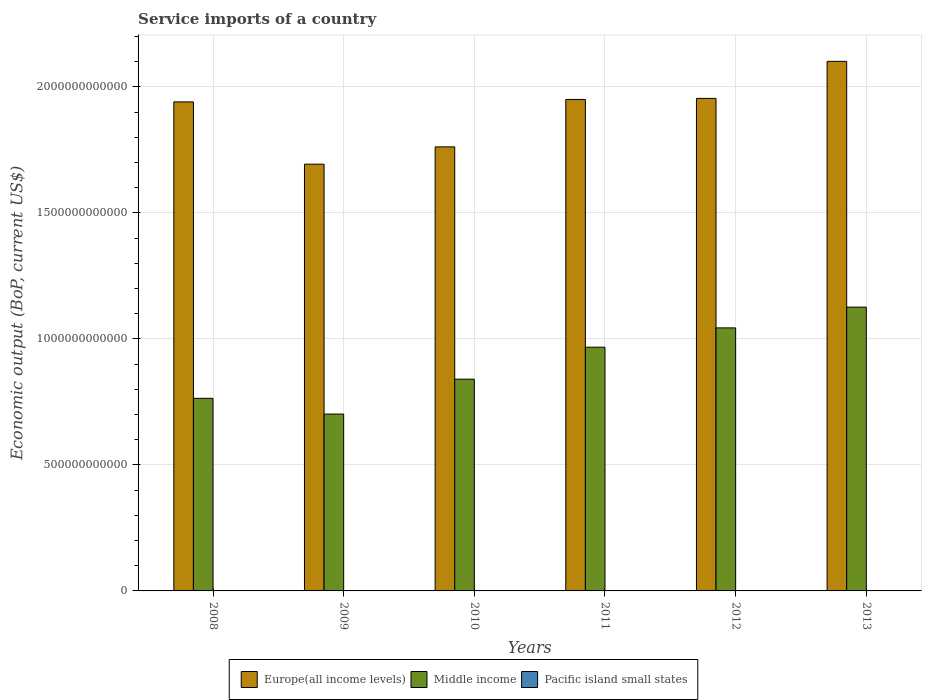How many different coloured bars are there?
Provide a succinct answer. 3. Are the number of bars on each tick of the X-axis equal?
Your answer should be very brief. Yes. How many bars are there on the 4th tick from the left?
Your answer should be very brief. 3. In how many cases, is the number of bars for a given year not equal to the number of legend labels?
Give a very brief answer. 0. What is the service imports in Europe(all income levels) in 2009?
Ensure brevity in your answer.  1.69e+12. Across all years, what is the maximum service imports in Europe(all income levels)?
Provide a succinct answer. 2.10e+12. Across all years, what is the minimum service imports in Pacific island small states?
Keep it short and to the point. 1.04e+09. In which year was the service imports in Europe(all income levels) maximum?
Your answer should be compact. 2013. What is the total service imports in Pacific island small states in the graph?
Ensure brevity in your answer.  7.42e+09. What is the difference between the service imports in Europe(all income levels) in 2008 and that in 2013?
Your response must be concise. -1.61e+11. What is the difference between the service imports in Pacific island small states in 2008 and the service imports in Europe(all income levels) in 2009?
Give a very brief answer. -1.69e+12. What is the average service imports in Middle income per year?
Keep it short and to the point. 9.07e+11. In the year 2010, what is the difference between the service imports in Middle income and service imports in Europe(all income levels)?
Your answer should be very brief. -9.22e+11. In how many years, is the service imports in Pacific island small states greater than 2100000000000 US$?
Give a very brief answer. 0. What is the ratio of the service imports in Pacific island small states in 2009 to that in 2011?
Your answer should be very brief. 0.82. Is the service imports in Middle income in 2011 less than that in 2012?
Your response must be concise. Yes. Is the difference between the service imports in Middle income in 2008 and 2011 greater than the difference between the service imports in Europe(all income levels) in 2008 and 2011?
Make the answer very short. No. What is the difference between the highest and the second highest service imports in Pacific island small states?
Offer a very short reply. 2.58e+07. What is the difference between the highest and the lowest service imports in Middle income?
Give a very brief answer. 4.24e+11. Is the sum of the service imports in Europe(all income levels) in 2010 and 2013 greater than the maximum service imports in Middle income across all years?
Offer a terse response. Yes. What does the 1st bar from the left in 2010 represents?
Keep it short and to the point. Europe(all income levels). What does the 1st bar from the right in 2011 represents?
Make the answer very short. Pacific island small states. Are all the bars in the graph horizontal?
Ensure brevity in your answer.  No. How many years are there in the graph?
Offer a terse response. 6. What is the difference between two consecutive major ticks on the Y-axis?
Ensure brevity in your answer.  5.00e+11. How are the legend labels stacked?
Provide a succinct answer. Horizontal. What is the title of the graph?
Provide a short and direct response. Service imports of a country. Does "Ghana" appear as one of the legend labels in the graph?
Keep it short and to the point. No. What is the label or title of the Y-axis?
Keep it short and to the point. Economic output (BoP, current US$). What is the Economic output (BoP, current US$) in Europe(all income levels) in 2008?
Provide a succinct answer. 1.94e+12. What is the Economic output (BoP, current US$) of Middle income in 2008?
Provide a succinct answer. 7.64e+11. What is the Economic output (BoP, current US$) of Pacific island small states in 2008?
Your answer should be compact. 1.25e+09. What is the Economic output (BoP, current US$) of Europe(all income levels) in 2009?
Your answer should be compact. 1.69e+12. What is the Economic output (BoP, current US$) in Middle income in 2009?
Your response must be concise. 7.02e+11. What is the Economic output (BoP, current US$) of Pacific island small states in 2009?
Ensure brevity in your answer.  1.04e+09. What is the Economic output (BoP, current US$) in Europe(all income levels) in 2010?
Ensure brevity in your answer.  1.76e+12. What is the Economic output (BoP, current US$) in Middle income in 2010?
Provide a succinct answer. 8.40e+11. What is the Economic output (BoP, current US$) of Pacific island small states in 2010?
Your answer should be very brief. 1.12e+09. What is the Economic output (BoP, current US$) of Europe(all income levels) in 2011?
Give a very brief answer. 1.95e+12. What is the Economic output (BoP, current US$) in Middle income in 2011?
Your answer should be very brief. 9.67e+11. What is the Economic output (BoP, current US$) of Pacific island small states in 2011?
Make the answer very short. 1.27e+09. What is the Economic output (BoP, current US$) of Europe(all income levels) in 2012?
Make the answer very short. 1.95e+12. What is the Economic output (BoP, current US$) of Middle income in 2012?
Your response must be concise. 1.04e+12. What is the Economic output (BoP, current US$) of Pacific island small states in 2012?
Give a very brief answer. 1.36e+09. What is the Economic output (BoP, current US$) in Europe(all income levels) in 2013?
Give a very brief answer. 2.10e+12. What is the Economic output (BoP, current US$) in Middle income in 2013?
Keep it short and to the point. 1.13e+12. What is the Economic output (BoP, current US$) in Pacific island small states in 2013?
Keep it short and to the point. 1.38e+09. Across all years, what is the maximum Economic output (BoP, current US$) in Europe(all income levels)?
Provide a short and direct response. 2.10e+12. Across all years, what is the maximum Economic output (BoP, current US$) in Middle income?
Ensure brevity in your answer.  1.13e+12. Across all years, what is the maximum Economic output (BoP, current US$) of Pacific island small states?
Your answer should be compact. 1.38e+09. Across all years, what is the minimum Economic output (BoP, current US$) of Europe(all income levels)?
Your response must be concise. 1.69e+12. Across all years, what is the minimum Economic output (BoP, current US$) of Middle income?
Make the answer very short. 7.02e+11. Across all years, what is the minimum Economic output (BoP, current US$) of Pacific island small states?
Provide a short and direct response. 1.04e+09. What is the total Economic output (BoP, current US$) of Europe(all income levels) in the graph?
Your answer should be compact. 1.14e+13. What is the total Economic output (BoP, current US$) in Middle income in the graph?
Provide a short and direct response. 5.44e+12. What is the total Economic output (BoP, current US$) of Pacific island small states in the graph?
Offer a very short reply. 7.42e+09. What is the difference between the Economic output (BoP, current US$) of Europe(all income levels) in 2008 and that in 2009?
Offer a very short reply. 2.47e+11. What is the difference between the Economic output (BoP, current US$) of Middle income in 2008 and that in 2009?
Offer a terse response. 6.24e+1. What is the difference between the Economic output (BoP, current US$) in Pacific island small states in 2008 and that in 2009?
Your answer should be compact. 2.09e+08. What is the difference between the Economic output (BoP, current US$) in Europe(all income levels) in 2008 and that in 2010?
Provide a short and direct response. 1.78e+11. What is the difference between the Economic output (BoP, current US$) of Middle income in 2008 and that in 2010?
Your response must be concise. -7.60e+1. What is the difference between the Economic output (BoP, current US$) of Pacific island small states in 2008 and that in 2010?
Ensure brevity in your answer.  1.35e+08. What is the difference between the Economic output (BoP, current US$) in Europe(all income levels) in 2008 and that in 2011?
Your answer should be compact. -9.67e+09. What is the difference between the Economic output (BoP, current US$) of Middle income in 2008 and that in 2011?
Give a very brief answer. -2.03e+11. What is the difference between the Economic output (BoP, current US$) of Pacific island small states in 2008 and that in 2011?
Ensure brevity in your answer.  -2.08e+07. What is the difference between the Economic output (BoP, current US$) of Europe(all income levels) in 2008 and that in 2012?
Provide a short and direct response. -1.39e+1. What is the difference between the Economic output (BoP, current US$) of Middle income in 2008 and that in 2012?
Provide a short and direct response. -2.80e+11. What is the difference between the Economic output (BoP, current US$) in Pacific island small states in 2008 and that in 2012?
Your answer should be compact. -1.06e+08. What is the difference between the Economic output (BoP, current US$) of Europe(all income levels) in 2008 and that in 2013?
Keep it short and to the point. -1.61e+11. What is the difference between the Economic output (BoP, current US$) of Middle income in 2008 and that in 2013?
Provide a short and direct response. -3.62e+11. What is the difference between the Economic output (BoP, current US$) in Pacific island small states in 2008 and that in 2013?
Offer a terse response. -1.32e+08. What is the difference between the Economic output (BoP, current US$) in Europe(all income levels) in 2009 and that in 2010?
Provide a succinct answer. -6.86e+1. What is the difference between the Economic output (BoP, current US$) in Middle income in 2009 and that in 2010?
Ensure brevity in your answer.  -1.38e+11. What is the difference between the Economic output (BoP, current US$) in Pacific island small states in 2009 and that in 2010?
Your answer should be very brief. -7.35e+07. What is the difference between the Economic output (BoP, current US$) in Europe(all income levels) in 2009 and that in 2011?
Provide a succinct answer. -2.57e+11. What is the difference between the Economic output (BoP, current US$) in Middle income in 2009 and that in 2011?
Provide a succinct answer. -2.65e+11. What is the difference between the Economic output (BoP, current US$) of Pacific island small states in 2009 and that in 2011?
Your answer should be very brief. -2.29e+08. What is the difference between the Economic output (BoP, current US$) in Europe(all income levels) in 2009 and that in 2012?
Your response must be concise. -2.61e+11. What is the difference between the Economic output (BoP, current US$) in Middle income in 2009 and that in 2012?
Offer a terse response. -3.42e+11. What is the difference between the Economic output (BoP, current US$) of Pacific island small states in 2009 and that in 2012?
Keep it short and to the point. -3.15e+08. What is the difference between the Economic output (BoP, current US$) in Europe(all income levels) in 2009 and that in 2013?
Your answer should be very brief. -4.08e+11. What is the difference between the Economic output (BoP, current US$) in Middle income in 2009 and that in 2013?
Your response must be concise. -4.24e+11. What is the difference between the Economic output (BoP, current US$) of Pacific island small states in 2009 and that in 2013?
Ensure brevity in your answer.  -3.41e+08. What is the difference between the Economic output (BoP, current US$) of Europe(all income levels) in 2010 and that in 2011?
Offer a terse response. -1.88e+11. What is the difference between the Economic output (BoP, current US$) of Middle income in 2010 and that in 2011?
Ensure brevity in your answer.  -1.27e+11. What is the difference between the Economic output (BoP, current US$) of Pacific island small states in 2010 and that in 2011?
Offer a very short reply. -1.56e+08. What is the difference between the Economic output (BoP, current US$) of Europe(all income levels) in 2010 and that in 2012?
Provide a short and direct response. -1.92e+11. What is the difference between the Economic output (BoP, current US$) in Middle income in 2010 and that in 2012?
Provide a short and direct response. -2.04e+11. What is the difference between the Economic output (BoP, current US$) in Pacific island small states in 2010 and that in 2012?
Your response must be concise. -2.41e+08. What is the difference between the Economic output (BoP, current US$) of Europe(all income levels) in 2010 and that in 2013?
Provide a succinct answer. -3.39e+11. What is the difference between the Economic output (BoP, current US$) of Middle income in 2010 and that in 2013?
Provide a short and direct response. -2.86e+11. What is the difference between the Economic output (BoP, current US$) in Pacific island small states in 2010 and that in 2013?
Give a very brief answer. -2.67e+08. What is the difference between the Economic output (BoP, current US$) of Europe(all income levels) in 2011 and that in 2012?
Offer a very short reply. -4.20e+09. What is the difference between the Economic output (BoP, current US$) in Middle income in 2011 and that in 2012?
Provide a short and direct response. -7.66e+1. What is the difference between the Economic output (BoP, current US$) in Pacific island small states in 2011 and that in 2012?
Offer a terse response. -8.54e+07. What is the difference between the Economic output (BoP, current US$) of Europe(all income levels) in 2011 and that in 2013?
Keep it short and to the point. -1.51e+11. What is the difference between the Economic output (BoP, current US$) of Middle income in 2011 and that in 2013?
Offer a terse response. -1.59e+11. What is the difference between the Economic output (BoP, current US$) of Pacific island small states in 2011 and that in 2013?
Provide a succinct answer. -1.11e+08. What is the difference between the Economic output (BoP, current US$) of Europe(all income levels) in 2012 and that in 2013?
Ensure brevity in your answer.  -1.47e+11. What is the difference between the Economic output (BoP, current US$) in Middle income in 2012 and that in 2013?
Offer a very short reply. -8.24e+1. What is the difference between the Economic output (BoP, current US$) of Pacific island small states in 2012 and that in 2013?
Give a very brief answer. -2.58e+07. What is the difference between the Economic output (BoP, current US$) in Europe(all income levels) in 2008 and the Economic output (BoP, current US$) in Middle income in 2009?
Give a very brief answer. 1.24e+12. What is the difference between the Economic output (BoP, current US$) in Europe(all income levels) in 2008 and the Economic output (BoP, current US$) in Pacific island small states in 2009?
Your answer should be compact. 1.94e+12. What is the difference between the Economic output (BoP, current US$) in Middle income in 2008 and the Economic output (BoP, current US$) in Pacific island small states in 2009?
Give a very brief answer. 7.63e+11. What is the difference between the Economic output (BoP, current US$) of Europe(all income levels) in 2008 and the Economic output (BoP, current US$) of Middle income in 2010?
Your answer should be compact. 1.10e+12. What is the difference between the Economic output (BoP, current US$) of Europe(all income levels) in 2008 and the Economic output (BoP, current US$) of Pacific island small states in 2010?
Offer a terse response. 1.94e+12. What is the difference between the Economic output (BoP, current US$) in Middle income in 2008 and the Economic output (BoP, current US$) in Pacific island small states in 2010?
Offer a terse response. 7.63e+11. What is the difference between the Economic output (BoP, current US$) in Europe(all income levels) in 2008 and the Economic output (BoP, current US$) in Middle income in 2011?
Provide a succinct answer. 9.73e+11. What is the difference between the Economic output (BoP, current US$) in Europe(all income levels) in 2008 and the Economic output (BoP, current US$) in Pacific island small states in 2011?
Your response must be concise. 1.94e+12. What is the difference between the Economic output (BoP, current US$) of Middle income in 2008 and the Economic output (BoP, current US$) of Pacific island small states in 2011?
Provide a succinct answer. 7.63e+11. What is the difference between the Economic output (BoP, current US$) in Europe(all income levels) in 2008 and the Economic output (BoP, current US$) in Middle income in 2012?
Offer a very short reply. 8.97e+11. What is the difference between the Economic output (BoP, current US$) of Europe(all income levels) in 2008 and the Economic output (BoP, current US$) of Pacific island small states in 2012?
Ensure brevity in your answer.  1.94e+12. What is the difference between the Economic output (BoP, current US$) of Middle income in 2008 and the Economic output (BoP, current US$) of Pacific island small states in 2012?
Offer a terse response. 7.63e+11. What is the difference between the Economic output (BoP, current US$) of Europe(all income levels) in 2008 and the Economic output (BoP, current US$) of Middle income in 2013?
Make the answer very short. 8.14e+11. What is the difference between the Economic output (BoP, current US$) in Europe(all income levels) in 2008 and the Economic output (BoP, current US$) in Pacific island small states in 2013?
Offer a terse response. 1.94e+12. What is the difference between the Economic output (BoP, current US$) in Middle income in 2008 and the Economic output (BoP, current US$) in Pacific island small states in 2013?
Keep it short and to the point. 7.63e+11. What is the difference between the Economic output (BoP, current US$) of Europe(all income levels) in 2009 and the Economic output (BoP, current US$) of Middle income in 2010?
Your answer should be compact. 8.53e+11. What is the difference between the Economic output (BoP, current US$) in Europe(all income levels) in 2009 and the Economic output (BoP, current US$) in Pacific island small states in 2010?
Keep it short and to the point. 1.69e+12. What is the difference between the Economic output (BoP, current US$) in Middle income in 2009 and the Economic output (BoP, current US$) in Pacific island small states in 2010?
Keep it short and to the point. 7.01e+11. What is the difference between the Economic output (BoP, current US$) in Europe(all income levels) in 2009 and the Economic output (BoP, current US$) in Middle income in 2011?
Offer a terse response. 7.26e+11. What is the difference between the Economic output (BoP, current US$) of Europe(all income levels) in 2009 and the Economic output (BoP, current US$) of Pacific island small states in 2011?
Provide a short and direct response. 1.69e+12. What is the difference between the Economic output (BoP, current US$) of Middle income in 2009 and the Economic output (BoP, current US$) of Pacific island small states in 2011?
Your answer should be very brief. 7.00e+11. What is the difference between the Economic output (BoP, current US$) in Europe(all income levels) in 2009 and the Economic output (BoP, current US$) in Middle income in 2012?
Provide a succinct answer. 6.50e+11. What is the difference between the Economic output (BoP, current US$) of Europe(all income levels) in 2009 and the Economic output (BoP, current US$) of Pacific island small states in 2012?
Ensure brevity in your answer.  1.69e+12. What is the difference between the Economic output (BoP, current US$) in Middle income in 2009 and the Economic output (BoP, current US$) in Pacific island small states in 2012?
Your response must be concise. 7.00e+11. What is the difference between the Economic output (BoP, current US$) in Europe(all income levels) in 2009 and the Economic output (BoP, current US$) in Middle income in 2013?
Offer a very short reply. 5.67e+11. What is the difference between the Economic output (BoP, current US$) of Europe(all income levels) in 2009 and the Economic output (BoP, current US$) of Pacific island small states in 2013?
Provide a short and direct response. 1.69e+12. What is the difference between the Economic output (BoP, current US$) in Middle income in 2009 and the Economic output (BoP, current US$) in Pacific island small states in 2013?
Ensure brevity in your answer.  7.00e+11. What is the difference between the Economic output (BoP, current US$) in Europe(all income levels) in 2010 and the Economic output (BoP, current US$) in Middle income in 2011?
Keep it short and to the point. 7.95e+11. What is the difference between the Economic output (BoP, current US$) of Europe(all income levels) in 2010 and the Economic output (BoP, current US$) of Pacific island small states in 2011?
Offer a very short reply. 1.76e+12. What is the difference between the Economic output (BoP, current US$) of Middle income in 2010 and the Economic output (BoP, current US$) of Pacific island small states in 2011?
Provide a short and direct response. 8.39e+11. What is the difference between the Economic output (BoP, current US$) in Europe(all income levels) in 2010 and the Economic output (BoP, current US$) in Middle income in 2012?
Your answer should be very brief. 7.18e+11. What is the difference between the Economic output (BoP, current US$) of Europe(all income levels) in 2010 and the Economic output (BoP, current US$) of Pacific island small states in 2012?
Offer a very short reply. 1.76e+12. What is the difference between the Economic output (BoP, current US$) of Middle income in 2010 and the Economic output (BoP, current US$) of Pacific island small states in 2012?
Keep it short and to the point. 8.39e+11. What is the difference between the Economic output (BoP, current US$) in Europe(all income levels) in 2010 and the Economic output (BoP, current US$) in Middle income in 2013?
Provide a short and direct response. 6.36e+11. What is the difference between the Economic output (BoP, current US$) in Europe(all income levels) in 2010 and the Economic output (BoP, current US$) in Pacific island small states in 2013?
Make the answer very short. 1.76e+12. What is the difference between the Economic output (BoP, current US$) of Middle income in 2010 and the Economic output (BoP, current US$) of Pacific island small states in 2013?
Your answer should be very brief. 8.39e+11. What is the difference between the Economic output (BoP, current US$) of Europe(all income levels) in 2011 and the Economic output (BoP, current US$) of Middle income in 2012?
Give a very brief answer. 9.06e+11. What is the difference between the Economic output (BoP, current US$) of Europe(all income levels) in 2011 and the Economic output (BoP, current US$) of Pacific island small states in 2012?
Ensure brevity in your answer.  1.95e+12. What is the difference between the Economic output (BoP, current US$) of Middle income in 2011 and the Economic output (BoP, current US$) of Pacific island small states in 2012?
Your answer should be compact. 9.66e+11. What is the difference between the Economic output (BoP, current US$) in Europe(all income levels) in 2011 and the Economic output (BoP, current US$) in Middle income in 2013?
Your answer should be compact. 8.24e+11. What is the difference between the Economic output (BoP, current US$) of Europe(all income levels) in 2011 and the Economic output (BoP, current US$) of Pacific island small states in 2013?
Your answer should be compact. 1.95e+12. What is the difference between the Economic output (BoP, current US$) in Middle income in 2011 and the Economic output (BoP, current US$) in Pacific island small states in 2013?
Provide a succinct answer. 9.66e+11. What is the difference between the Economic output (BoP, current US$) of Europe(all income levels) in 2012 and the Economic output (BoP, current US$) of Middle income in 2013?
Offer a very short reply. 8.28e+11. What is the difference between the Economic output (BoP, current US$) of Europe(all income levels) in 2012 and the Economic output (BoP, current US$) of Pacific island small states in 2013?
Keep it short and to the point. 1.95e+12. What is the difference between the Economic output (BoP, current US$) in Middle income in 2012 and the Economic output (BoP, current US$) in Pacific island small states in 2013?
Your response must be concise. 1.04e+12. What is the average Economic output (BoP, current US$) in Europe(all income levels) per year?
Make the answer very short. 1.90e+12. What is the average Economic output (BoP, current US$) in Middle income per year?
Provide a succinct answer. 9.07e+11. What is the average Economic output (BoP, current US$) in Pacific island small states per year?
Your answer should be compact. 1.24e+09. In the year 2008, what is the difference between the Economic output (BoP, current US$) of Europe(all income levels) and Economic output (BoP, current US$) of Middle income?
Offer a very short reply. 1.18e+12. In the year 2008, what is the difference between the Economic output (BoP, current US$) of Europe(all income levels) and Economic output (BoP, current US$) of Pacific island small states?
Offer a terse response. 1.94e+12. In the year 2008, what is the difference between the Economic output (BoP, current US$) in Middle income and Economic output (BoP, current US$) in Pacific island small states?
Make the answer very short. 7.63e+11. In the year 2009, what is the difference between the Economic output (BoP, current US$) in Europe(all income levels) and Economic output (BoP, current US$) in Middle income?
Ensure brevity in your answer.  9.91e+11. In the year 2009, what is the difference between the Economic output (BoP, current US$) in Europe(all income levels) and Economic output (BoP, current US$) in Pacific island small states?
Provide a short and direct response. 1.69e+12. In the year 2009, what is the difference between the Economic output (BoP, current US$) in Middle income and Economic output (BoP, current US$) in Pacific island small states?
Provide a succinct answer. 7.01e+11. In the year 2010, what is the difference between the Economic output (BoP, current US$) in Europe(all income levels) and Economic output (BoP, current US$) in Middle income?
Make the answer very short. 9.22e+11. In the year 2010, what is the difference between the Economic output (BoP, current US$) of Europe(all income levels) and Economic output (BoP, current US$) of Pacific island small states?
Your answer should be compact. 1.76e+12. In the year 2010, what is the difference between the Economic output (BoP, current US$) of Middle income and Economic output (BoP, current US$) of Pacific island small states?
Give a very brief answer. 8.39e+11. In the year 2011, what is the difference between the Economic output (BoP, current US$) in Europe(all income levels) and Economic output (BoP, current US$) in Middle income?
Provide a short and direct response. 9.83e+11. In the year 2011, what is the difference between the Economic output (BoP, current US$) of Europe(all income levels) and Economic output (BoP, current US$) of Pacific island small states?
Ensure brevity in your answer.  1.95e+12. In the year 2011, what is the difference between the Economic output (BoP, current US$) of Middle income and Economic output (BoP, current US$) of Pacific island small states?
Provide a succinct answer. 9.66e+11. In the year 2012, what is the difference between the Economic output (BoP, current US$) of Europe(all income levels) and Economic output (BoP, current US$) of Middle income?
Ensure brevity in your answer.  9.10e+11. In the year 2012, what is the difference between the Economic output (BoP, current US$) of Europe(all income levels) and Economic output (BoP, current US$) of Pacific island small states?
Ensure brevity in your answer.  1.95e+12. In the year 2012, what is the difference between the Economic output (BoP, current US$) in Middle income and Economic output (BoP, current US$) in Pacific island small states?
Offer a very short reply. 1.04e+12. In the year 2013, what is the difference between the Economic output (BoP, current US$) of Europe(all income levels) and Economic output (BoP, current US$) of Middle income?
Provide a succinct answer. 9.75e+11. In the year 2013, what is the difference between the Economic output (BoP, current US$) of Europe(all income levels) and Economic output (BoP, current US$) of Pacific island small states?
Ensure brevity in your answer.  2.10e+12. In the year 2013, what is the difference between the Economic output (BoP, current US$) of Middle income and Economic output (BoP, current US$) of Pacific island small states?
Your response must be concise. 1.12e+12. What is the ratio of the Economic output (BoP, current US$) of Europe(all income levels) in 2008 to that in 2009?
Your response must be concise. 1.15. What is the ratio of the Economic output (BoP, current US$) in Middle income in 2008 to that in 2009?
Offer a terse response. 1.09. What is the ratio of the Economic output (BoP, current US$) in Pacific island small states in 2008 to that in 2009?
Keep it short and to the point. 1.2. What is the ratio of the Economic output (BoP, current US$) of Europe(all income levels) in 2008 to that in 2010?
Offer a terse response. 1.1. What is the ratio of the Economic output (BoP, current US$) of Middle income in 2008 to that in 2010?
Give a very brief answer. 0.91. What is the ratio of the Economic output (BoP, current US$) of Pacific island small states in 2008 to that in 2010?
Give a very brief answer. 1.12. What is the ratio of the Economic output (BoP, current US$) in Middle income in 2008 to that in 2011?
Ensure brevity in your answer.  0.79. What is the ratio of the Economic output (BoP, current US$) of Pacific island small states in 2008 to that in 2011?
Keep it short and to the point. 0.98. What is the ratio of the Economic output (BoP, current US$) of Europe(all income levels) in 2008 to that in 2012?
Provide a succinct answer. 0.99. What is the ratio of the Economic output (BoP, current US$) of Middle income in 2008 to that in 2012?
Your response must be concise. 0.73. What is the ratio of the Economic output (BoP, current US$) of Pacific island small states in 2008 to that in 2012?
Offer a very short reply. 0.92. What is the ratio of the Economic output (BoP, current US$) of Europe(all income levels) in 2008 to that in 2013?
Offer a very short reply. 0.92. What is the ratio of the Economic output (BoP, current US$) in Middle income in 2008 to that in 2013?
Your answer should be compact. 0.68. What is the ratio of the Economic output (BoP, current US$) of Pacific island small states in 2008 to that in 2013?
Ensure brevity in your answer.  0.9. What is the ratio of the Economic output (BoP, current US$) of Europe(all income levels) in 2009 to that in 2010?
Ensure brevity in your answer.  0.96. What is the ratio of the Economic output (BoP, current US$) of Middle income in 2009 to that in 2010?
Your answer should be very brief. 0.84. What is the ratio of the Economic output (BoP, current US$) of Pacific island small states in 2009 to that in 2010?
Ensure brevity in your answer.  0.93. What is the ratio of the Economic output (BoP, current US$) of Europe(all income levels) in 2009 to that in 2011?
Your answer should be very brief. 0.87. What is the ratio of the Economic output (BoP, current US$) in Middle income in 2009 to that in 2011?
Provide a short and direct response. 0.73. What is the ratio of the Economic output (BoP, current US$) in Pacific island small states in 2009 to that in 2011?
Give a very brief answer. 0.82. What is the ratio of the Economic output (BoP, current US$) of Europe(all income levels) in 2009 to that in 2012?
Make the answer very short. 0.87. What is the ratio of the Economic output (BoP, current US$) in Middle income in 2009 to that in 2012?
Make the answer very short. 0.67. What is the ratio of the Economic output (BoP, current US$) in Pacific island small states in 2009 to that in 2012?
Give a very brief answer. 0.77. What is the ratio of the Economic output (BoP, current US$) of Europe(all income levels) in 2009 to that in 2013?
Keep it short and to the point. 0.81. What is the ratio of the Economic output (BoP, current US$) in Middle income in 2009 to that in 2013?
Provide a short and direct response. 0.62. What is the ratio of the Economic output (BoP, current US$) in Pacific island small states in 2009 to that in 2013?
Your response must be concise. 0.75. What is the ratio of the Economic output (BoP, current US$) in Europe(all income levels) in 2010 to that in 2011?
Make the answer very short. 0.9. What is the ratio of the Economic output (BoP, current US$) in Middle income in 2010 to that in 2011?
Provide a short and direct response. 0.87. What is the ratio of the Economic output (BoP, current US$) in Pacific island small states in 2010 to that in 2011?
Offer a terse response. 0.88. What is the ratio of the Economic output (BoP, current US$) in Europe(all income levels) in 2010 to that in 2012?
Your answer should be very brief. 0.9. What is the ratio of the Economic output (BoP, current US$) of Middle income in 2010 to that in 2012?
Provide a short and direct response. 0.81. What is the ratio of the Economic output (BoP, current US$) of Pacific island small states in 2010 to that in 2012?
Make the answer very short. 0.82. What is the ratio of the Economic output (BoP, current US$) in Europe(all income levels) in 2010 to that in 2013?
Your answer should be compact. 0.84. What is the ratio of the Economic output (BoP, current US$) in Middle income in 2010 to that in 2013?
Your answer should be compact. 0.75. What is the ratio of the Economic output (BoP, current US$) in Pacific island small states in 2010 to that in 2013?
Your response must be concise. 0.81. What is the ratio of the Economic output (BoP, current US$) of Middle income in 2011 to that in 2012?
Your response must be concise. 0.93. What is the ratio of the Economic output (BoP, current US$) of Pacific island small states in 2011 to that in 2012?
Your answer should be compact. 0.94. What is the ratio of the Economic output (BoP, current US$) in Europe(all income levels) in 2011 to that in 2013?
Make the answer very short. 0.93. What is the ratio of the Economic output (BoP, current US$) of Middle income in 2011 to that in 2013?
Provide a succinct answer. 0.86. What is the ratio of the Economic output (BoP, current US$) in Pacific island small states in 2011 to that in 2013?
Keep it short and to the point. 0.92. What is the ratio of the Economic output (BoP, current US$) of Middle income in 2012 to that in 2013?
Provide a short and direct response. 0.93. What is the ratio of the Economic output (BoP, current US$) of Pacific island small states in 2012 to that in 2013?
Provide a succinct answer. 0.98. What is the difference between the highest and the second highest Economic output (BoP, current US$) in Europe(all income levels)?
Keep it short and to the point. 1.47e+11. What is the difference between the highest and the second highest Economic output (BoP, current US$) of Middle income?
Provide a short and direct response. 8.24e+1. What is the difference between the highest and the second highest Economic output (BoP, current US$) in Pacific island small states?
Offer a terse response. 2.58e+07. What is the difference between the highest and the lowest Economic output (BoP, current US$) in Europe(all income levels)?
Offer a very short reply. 4.08e+11. What is the difference between the highest and the lowest Economic output (BoP, current US$) of Middle income?
Offer a very short reply. 4.24e+11. What is the difference between the highest and the lowest Economic output (BoP, current US$) in Pacific island small states?
Give a very brief answer. 3.41e+08. 